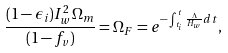<formula> <loc_0><loc_0><loc_500><loc_500>\frac { ( 1 - { \epsilon } _ { i } ) I _ { w } ^ { 2 } { \Omega } _ { m } } { ( 1 - f _ { v } ) } = { \Omega } _ { F } = e ^ { - \int _ { t _ { i } } ^ { t } \frac { \Lambda } { H _ { w } } d t } ,</formula> 